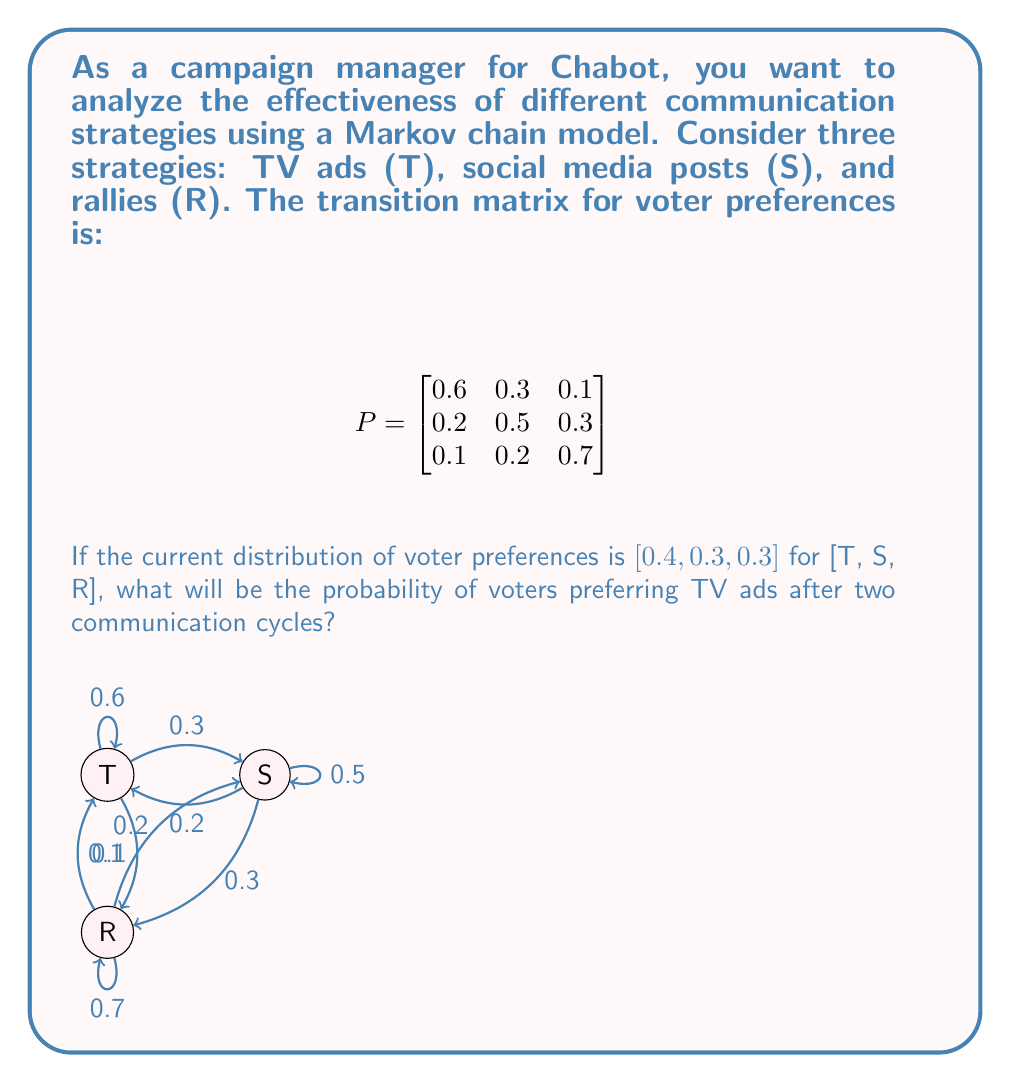Can you answer this question? Let's approach this step-by-step:

1) The initial distribution vector is:
   $$v_0 = [0.4, 0.3, 0.3]$$

2) To find the distribution after two cycles, we need to multiply $v_0$ by $P$ twice:
   $$v_2 = v_0 \cdot P^2$$

3) First, let's calculate $P^2$:
   $$P^2 = P \cdot P = \begin{bmatrix}
   0.6 & 0.3 & 0.1 \\
   0.2 & 0.5 & 0.3 \\
   0.1 & 0.2 & 0.7
   \end{bmatrix} \cdot \begin{bmatrix}
   0.6 & 0.3 & 0.1 \\
   0.2 & 0.5 & 0.3 \\
   0.1 & 0.2 & 0.7
   \end{bmatrix}$$

4) Performing the matrix multiplication:
   $$P^2 = \begin{bmatrix}
   0.44 & 0.33 & 0.23 \\
   0.29 & 0.40 & 0.31 \\
   0.19 & 0.28 & 0.53
   \end{bmatrix}$$

5) Now, we multiply $v_0$ by $P^2$:
   $$v_2 = [0.4, 0.3, 0.3] \cdot \begin{bmatrix}
   0.44 & 0.33 & 0.23 \\
   0.29 & 0.40 & 0.31 \\
   0.19 & 0.28 & 0.53
   \end{bmatrix}$$

6) Performing this multiplication:
   $$v_2 = [0.4(0.44) + 0.3(0.29) + 0.3(0.19), \ldots]$$
   $$v_2 = [0.318, 0.337, 0.345]$$

7) The probability of voters preferring TV ads after two cycles is the first element of $v_2$, which is 0.318 or 31.8%.
Answer: 0.318 or 31.8% 